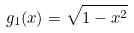<formula> <loc_0><loc_0><loc_500><loc_500>g _ { 1 } ( x ) = \sqrt { 1 - x ^ { 2 } }</formula> 